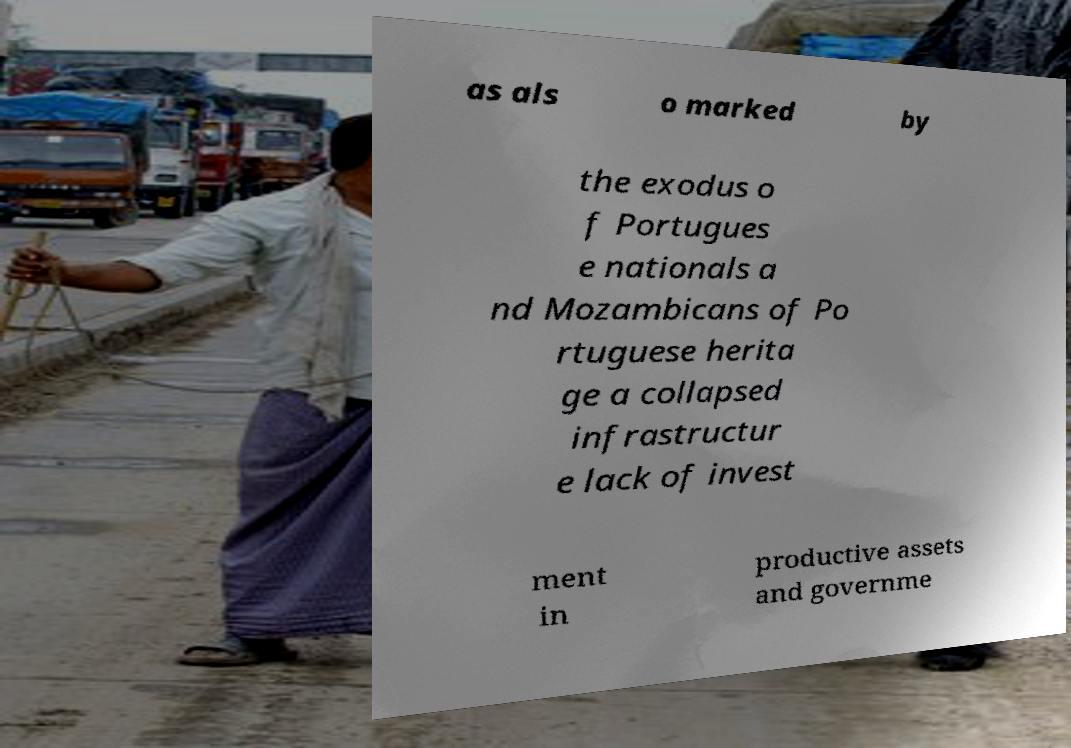For documentation purposes, I need the text within this image transcribed. Could you provide that? as als o marked by the exodus o f Portugues e nationals a nd Mozambicans of Po rtuguese herita ge a collapsed infrastructur e lack of invest ment in productive assets and governme 